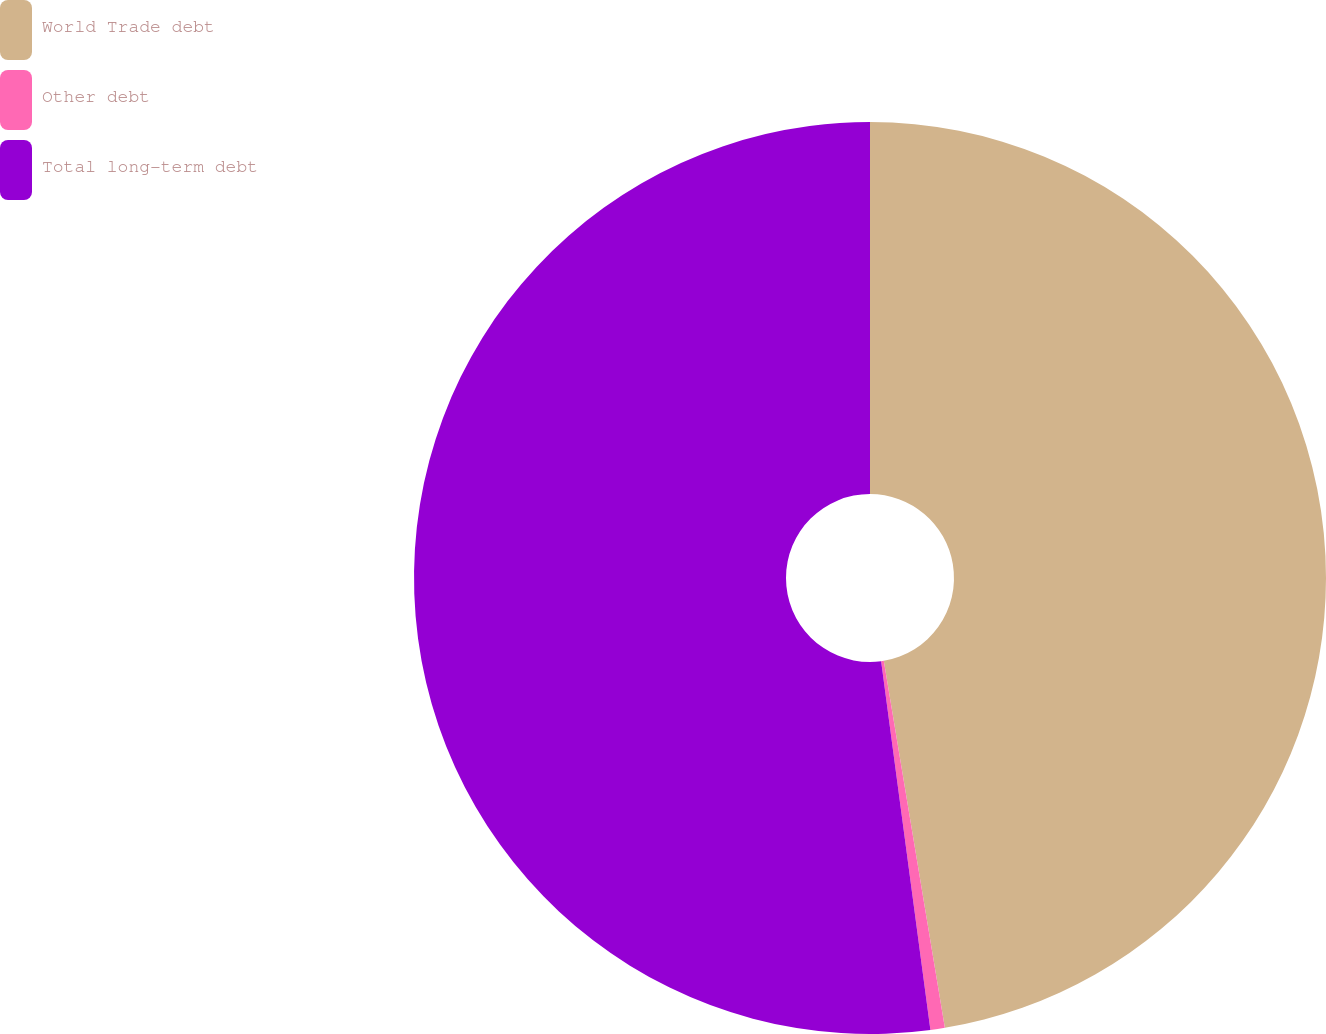Convert chart. <chart><loc_0><loc_0><loc_500><loc_500><pie_chart><fcel>World Trade debt<fcel>Other debt<fcel>Total long-term debt<nl><fcel>47.38%<fcel>0.51%<fcel>52.12%<nl></chart> 